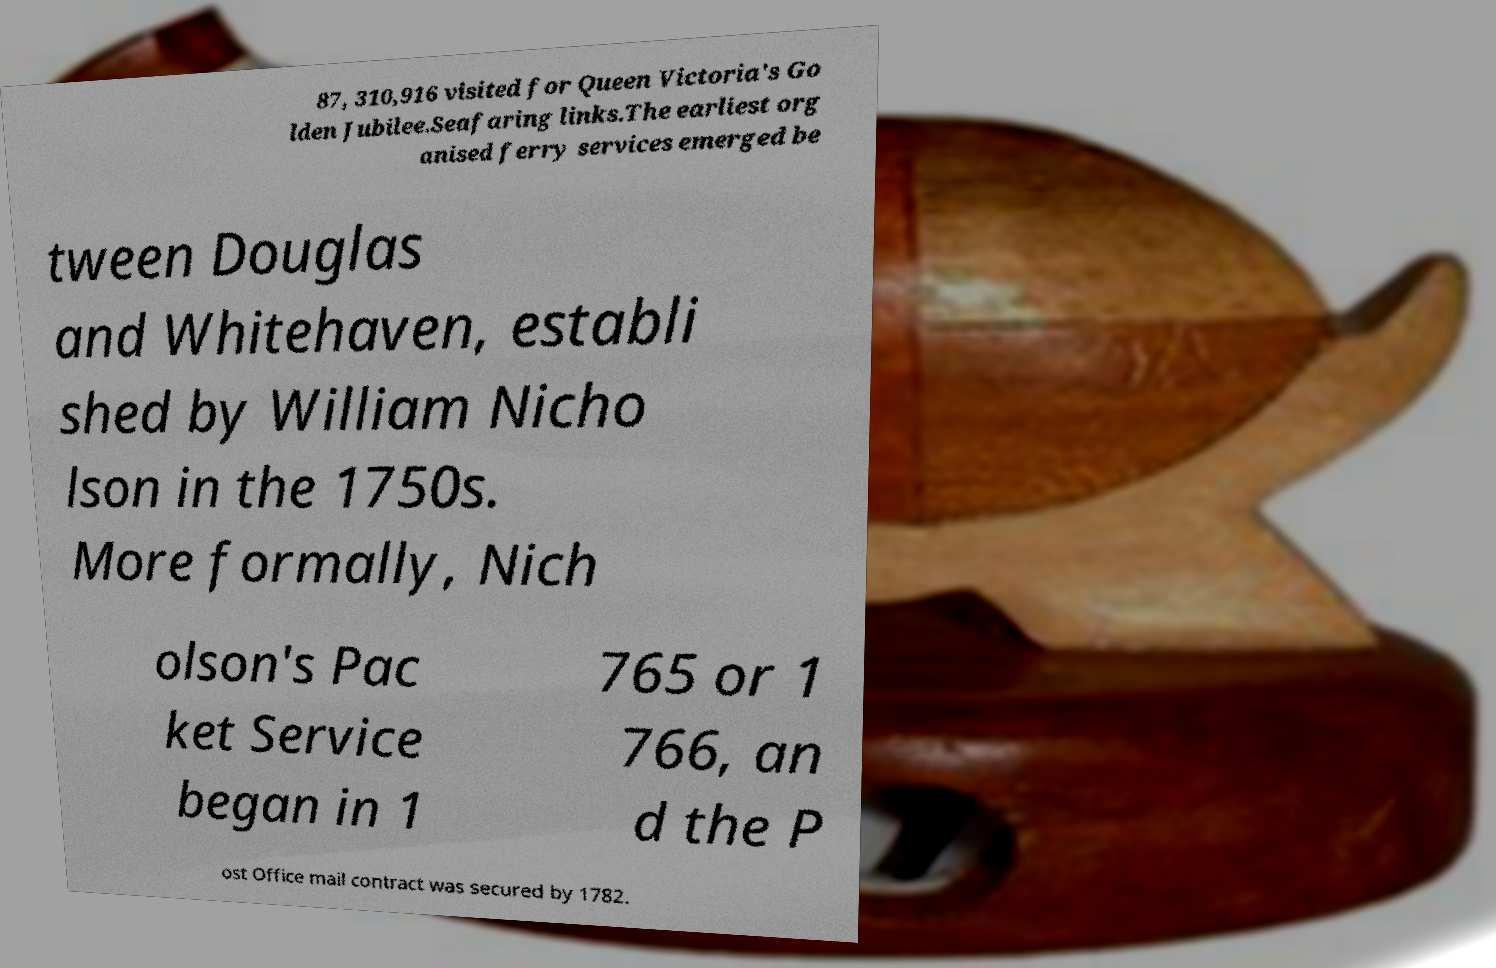Could you assist in decoding the text presented in this image and type it out clearly? 87, 310,916 visited for Queen Victoria's Go lden Jubilee.Seafaring links.The earliest org anised ferry services emerged be tween Douglas and Whitehaven, establi shed by William Nicho lson in the 1750s. More formally, Nich olson's Pac ket Service began in 1 765 or 1 766, an d the P ost Office mail contract was secured by 1782. 